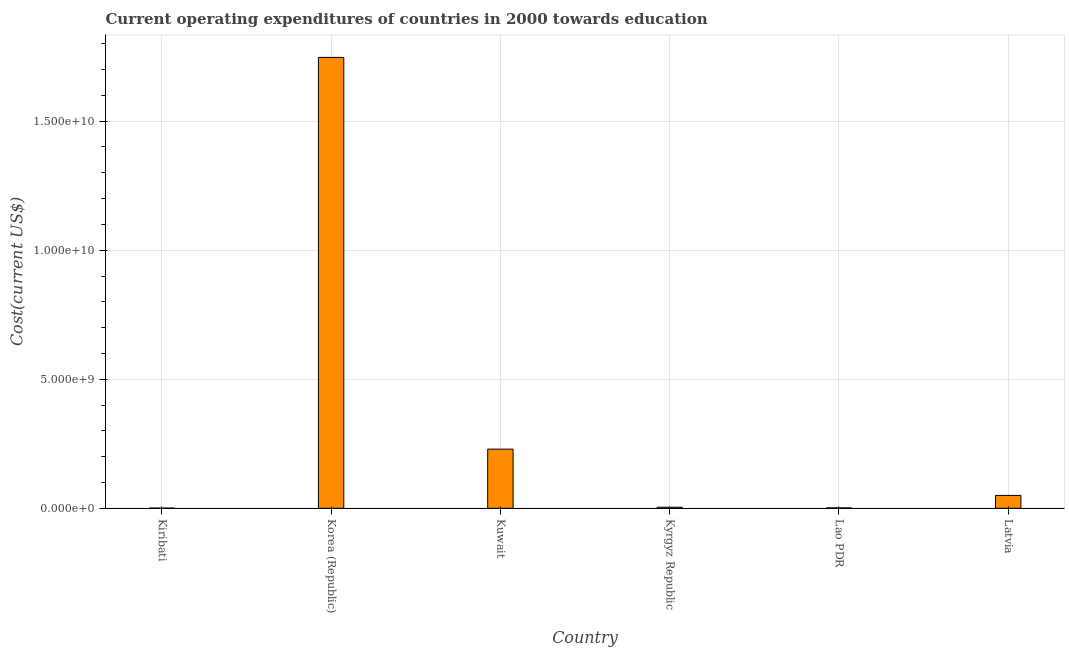Does the graph contain any zero values?
Your answer should be compact. No. What is the title of the graph?
Your answer should be very brief. Current operating expenditures of countries in 2000 towards education. What is the label or title of the X-axis?
Your answer should be very brief. Country. What is the label or title of the Y-axis?
Give a very brief answer. Cost(current US$). What is the education expenditure in Lao PDR?
Provide a succinct answer. 1.49e+07. Across all countries, what is the maximum education expenditure?
Give a very brief answer. 1.75e+1. Across all countries, what is the minimum education expenditure?
Your response must be concise. 6.67e+06. In which country was the education expenditure maximum?
Your response must be concise. Korea (Republic). In which country was the education expenditure minimum?
Your answer should be very brief. Kiribati. What is the sum of the education expenditure?
Your response must be concise. 2.03e+1. What is the difference between the education expenditure in Kyrgyz Republic and Lao PDR?
Your response must be concise. 2.50e+07. What is the average education expenditure per country?
Your answer should be very brief. 3.39e+09. What is the median education expenditure?
Make the answer very short. 2.69e+08. What is the ratio of the education expenditure in Kuwait to that in Kyrgyz Republic?
Your answer should be very brief. 57.41. Is the difference between the education expenditure in Kiribati and Kyrgyz Republic greater than the difference between any two countries?
Your response must be concise. No. What is the difference between the highest and the second highest education expenditure?
Your answer should be very brief. 1.52e+1. What is the difference between the highest and the lowest education expenditure?
Your answer should be very brief. 1.75e+1. In how many countries, is the education expenditure greater than the average education expenditure taken over all countries?
Provide a short and direct response. 1. How many bars are there?
Ensure brevity in your answer.  6. Are all the bars in the graph horizontal?
Your response must be concise. No. What is the difference between two consecutive major ticks on the Y-axis?
Give a very brief answer. 5.00e+09. What is the Cost(current US$) of Kiribati?
Your response must be concise. 6.67e+06. What is the Cost(current US$) in Korea (Republic)?
Make the answer very short. 1.75e+1. What is the Cost(current US$) in Kuwait?
Ensure brevity in your answer.  2.29e+09. What is the Cost(current US$) of Kyrgyz Republic?
Make the answer very short. 3.99e+07. What is the Cost(current US$) of Lao PDR?
Your answer should be very brief. 1.49e+07. What is the Cost(current US$) in Latvia?
Give a very brief answer. 4.98e+08. What is the difference between the Cost(current US$) in Kiribati and Korea (Republic)?
Provide a short and direct response. -1.75e+1. What is the difference between the Cost(current US$) in Kiribati and Kuwait?
Your answer should be compact. -2.29e+09. What is the difference between the Cost(current US$) in Kiribati and Kyrgyz Republic?
Make the answer very short. -3.33e+07. What is the difference between the Cost(current US$) in Kiribati and Lao PDR?
Give a very brief answer. -8.28e+06. What is the difference between the Cost(current US$) in Kiribati and Latvia?
Your response must be concise. -4.92e+08. What is the difference between the Cost(current US$) in Korea (Republic) and Kuwait?
Your answer should be very brief. 1.52e+1. What is the difference between the Cost(current US$) in Korea (Republic) and Kyrgyz Republic?
Provide a short and direct response. 1.74e+1. What is the difference between the Cost(current US$) in Korea (Republic) and Lao PDR?
Provide a short and direct response. 1.75e+1. What is the difference between the Cost(current US$) in Korea (Republic) and Latvia?
Your response must be concise. 1.70e+1. What is the difference between the Cost(current US$) in Kuwait and Kyrgyz Republic?
Your answer should be very brief. 2.25e+09. What is the difference between the Cost(current US$) in Kuwait and Lao PDR?
Offer a very short reply. 2.28e+09. What is the difference between the Cost(current US$) in Kuwait and Latvia?
Keep it short and to the point. 1.79e+09. What is the difference between the Cost(current US$) in Kyrgyz Republic and Lao PDR?
Give a very brief answer. 2.50e+07. What is the difference between the Cost(current US$) in Kyrgyz Republic and Latvia?
Offer a terse response. -4.58e+08. What is the difference between the Cost(current US$) in Lao PDR and Latvia?
Offer a terse response. -4.83e+08. What is the ratio of the Cost(current US$) in Kiribati to that in Korea (Republic)?
Your answer should be compact. 0. What is the ratio of the Cost(current US$) in Kiribati to that in Kuwait?
Make the answer very short. 0. What is the ratio of the Cost(current US$) in Kiribati to that in Kyrgyz Republic?
Your answer should be compact. 0.17. What is the ratio of the Cost(current US$) in Kiribati to that in Lao PDR?
Provide a succinct answer. 0.45. What is the ratio of the Cost(current US$) in Kiribati to that in Latvia?
Make the answer very short. 0.01. What is the ratio of the Cost(current US$) in Korea (Republic) to that in Kuwait?
Your answer should be compact. 7.62. What is the ratio of the Cost(current US$) in Korea (Republic) to that in Kyrgyz Republic?
Give a very brief answer. 437.67. What is the ratio of the Cost(current US$) in Korea (Republic) to that in Lao PDR?
Offer a terse response. 1169.14. What is the ratio of the Cost(current US$) in Korea (Republic) to that in Latvia?
Your answer should be very brief. 35.07. What is the ratio of the Cost(current US$) in Kuwait to that in Kyrgyz Republic?
Your answer should be very brief. 57.41. What is the ratio of the Cost(current US$) in Kuwait to that in Lao PDR?
Offer a terse response. 153.37. What is the ratio of the Cost(current US$) in Kuwait to that in Latvia?
Ensure brevity in your answer.  4.6. What is the ratio of the Cost(current US$) in Kyrgyz Republic to that in Lao PDR?
Offer a very short reply. 2.67. What is the ratio of the Cost(current US$) in Kyrgyz Republic to that in Latvia?
Provide a succinct answer. 0.08. What is the ratio of the Cost(current US$) in Lao PDR to that in Latvia?
Give a very brief answer. 0.03. 